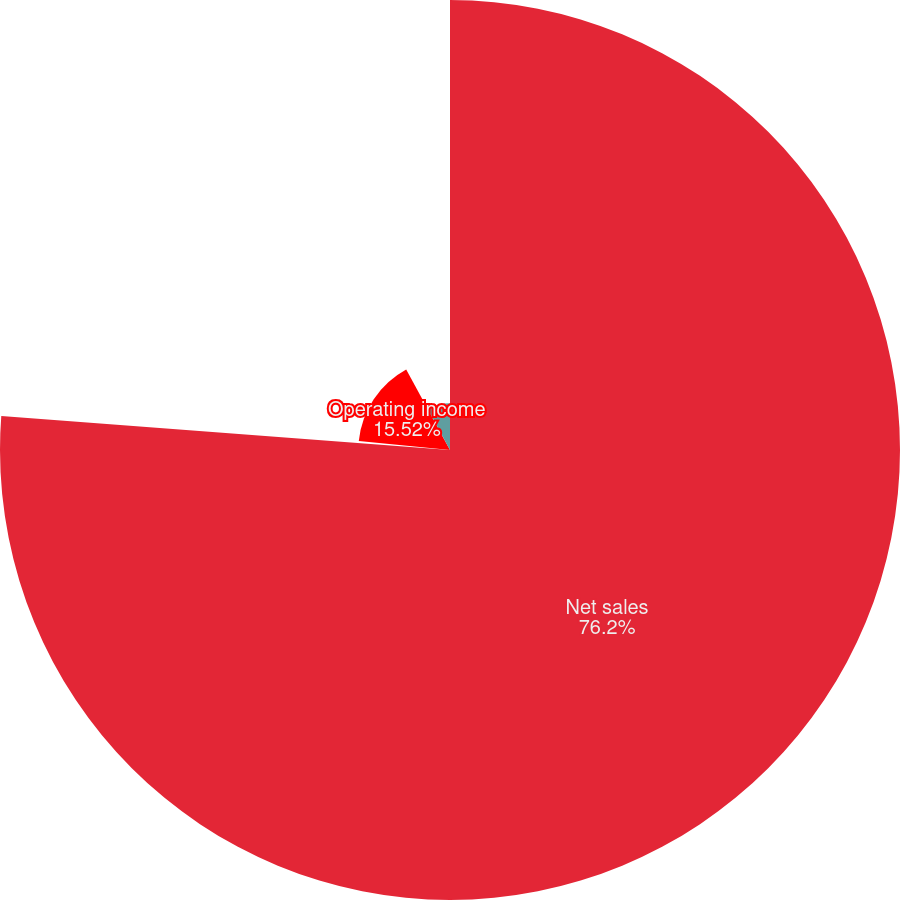<chart> <loc_0><loc_0><loc_500><loc_500><pie_chart><fcel>Net sales<fcel>Percent growth<fcel>Operating income<fcel>Operating income margin<nl><fcel>76.2%<fcel>0.35%<fcel>15.52%<fcel>7.93%<nl></chart> 